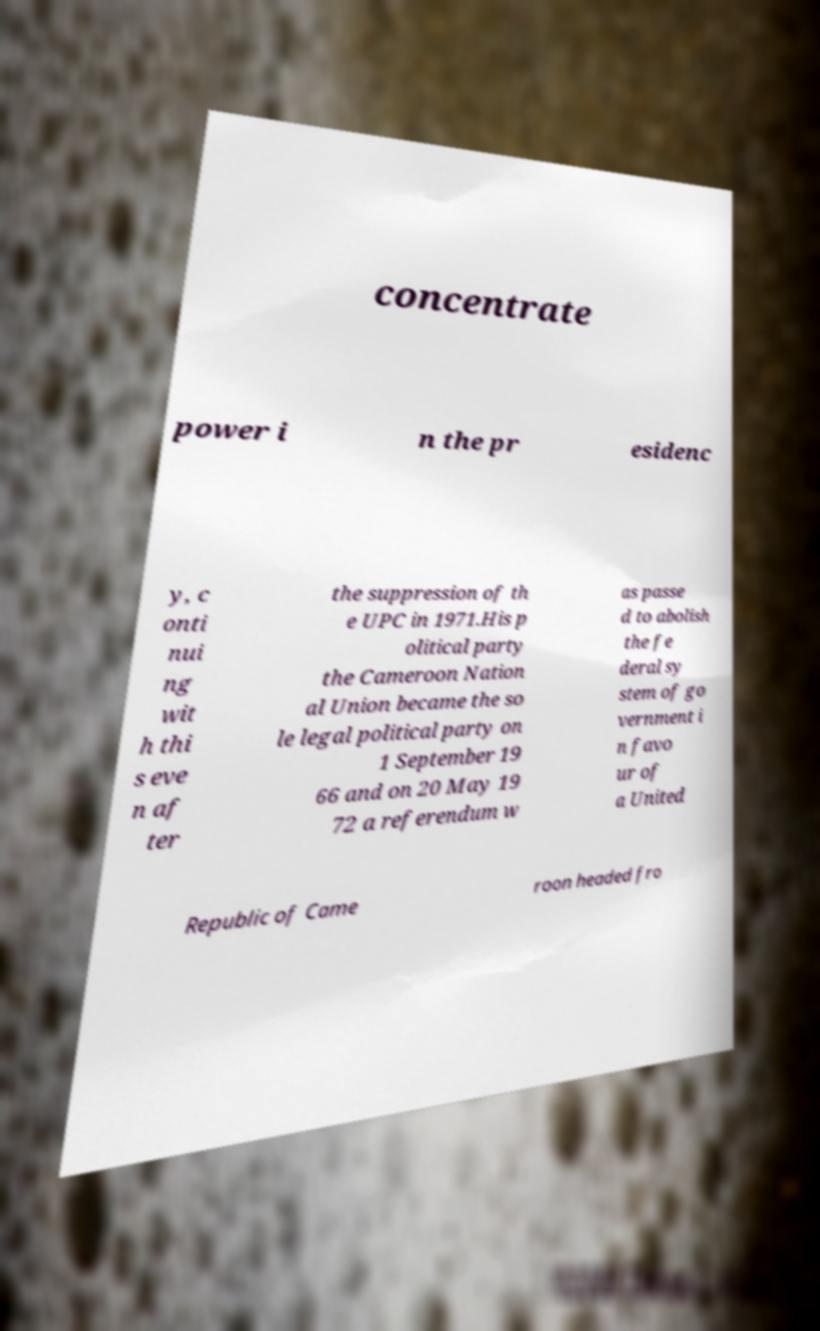For documentation purposes, I need the text within this image transcribed. Could you provide that? concentrate power i n the pr esidenc y, c onti nui ng wit h thi s eve n af ter the suppression of th e UPC in 1971.His p olitical party the Cameroon Nation al Union became the so le legal political party on 1 September 19 66 and on 20 May 19 72 a referendum w as passe d to abolish the fe deral sy stem of go vernment i n favo ur of a United Republic of Came roon headed fro 